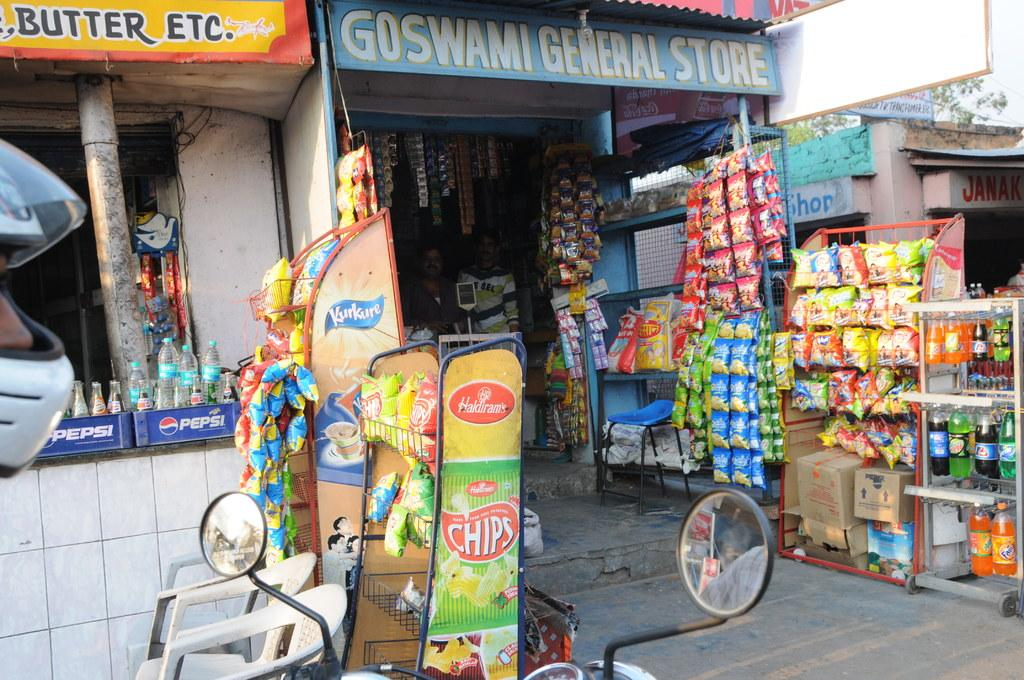<image>
Summarize the visual content of the image. Goswami General store that contains snacks and drinks 